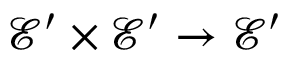Convert formula to latex. <formula><loc_0><loc_0><loc_500><loc_500>{ \mathcal { E } } ^ { \prime } \times { \mathcal { E } } ^ { \prime } \to { \mathcal { E } } ^ { \prime }</formula> 